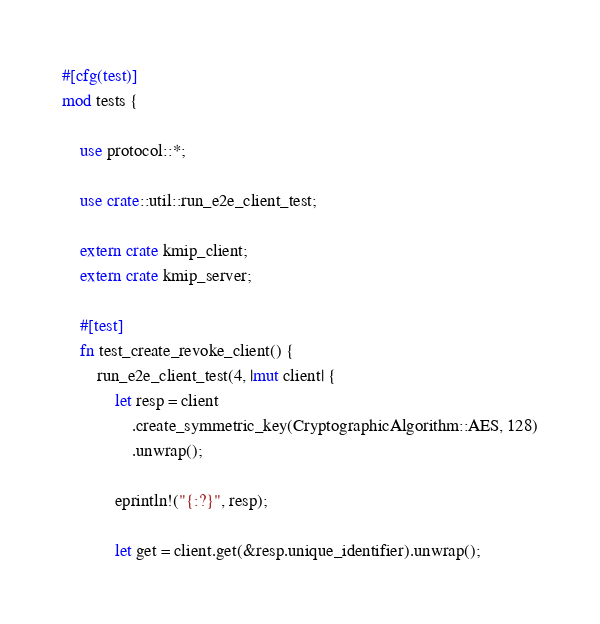Convert code to text. <code><loc_0><loc_0><loc_500><loc_500><_Rust_>#[cfg(test)]
mod tests {

    use protocol::*;

    use crate::util::run_e2e_client_test;

    extern crate kmip_client;
    extern crate kmip_server;

    #[test]
    fn test_create_revoke_client() {
        run_e2e_client_test(4, |mut client| {
            let resp = client
                .create_symmetric_key(CryptographicAlgorithm::AES, 128)
                .unwrap();

            eprintln!("{:?}", resp);

            let get = client.get(&resp.unique_identifier).unwrap();
</code> 